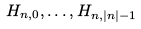Convert formula to latex. <formula><loc_0><loc_0><loc_500><loc_500>H _ { n , 0 } , \dots , H _ { n , | n | - 1 }</formula> 